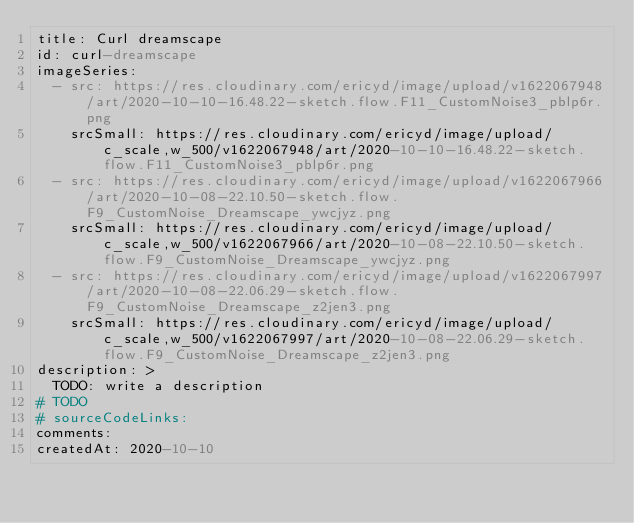<code> <loc_0><loc_0><loc_500><loc_500><_YAML_>title: Curl dreamscape
id: curl-dreamscape
imageSeries:
  - src: https://res.cloudinary.com/ericyd/image/upload/v1622067948/art/2020-10-10-16.48.22-sketch.flow.F11_CustomNoise3_pblp6r.png
    srcSmall: https://res.cloudinary.com/ericyd/image/upload/c_scale,w_500/v1622067948/art/2020-10-10-16.48.22-sketch.flow.F11_CustomNoise3_pblp6r.png
  - src: https://res.cloudinary.com/ericyd/image/upload/v1622067966/art/2020-10-08-22.10.50-sketch.flow.F9_CustomNoise_Dreamscape_ywcjyz.png
    srcSmall: https://res.cloudinary.com/ericyd/image/upload/c_scale,w_500/v1622067966/art/2020-10-08-22.10.50-sketch.flow.F9_CustomNoise_Dreamscape_ywcjyz.png
  - src: https://res.cloudinary.com/ericyd/image/upload/v1622067997/art/2020-10-08-22.06.29-sketch.flow.F9_CustomNoise_Dreamscape_z2jen3.png
    srcSmall: https://res.cloudinary.com/ericyd/image/upload/c_scale,w_500/v1622067997/art/2020-10-08-22.06.29-sketch.flow.F9_CustomNoise_Dreamscape_z2jen3.png
description: >
  TODO: write a description
# TODO
# sourceCodeLinks:
comments:
createdAt: 2020-10-10
</code> 